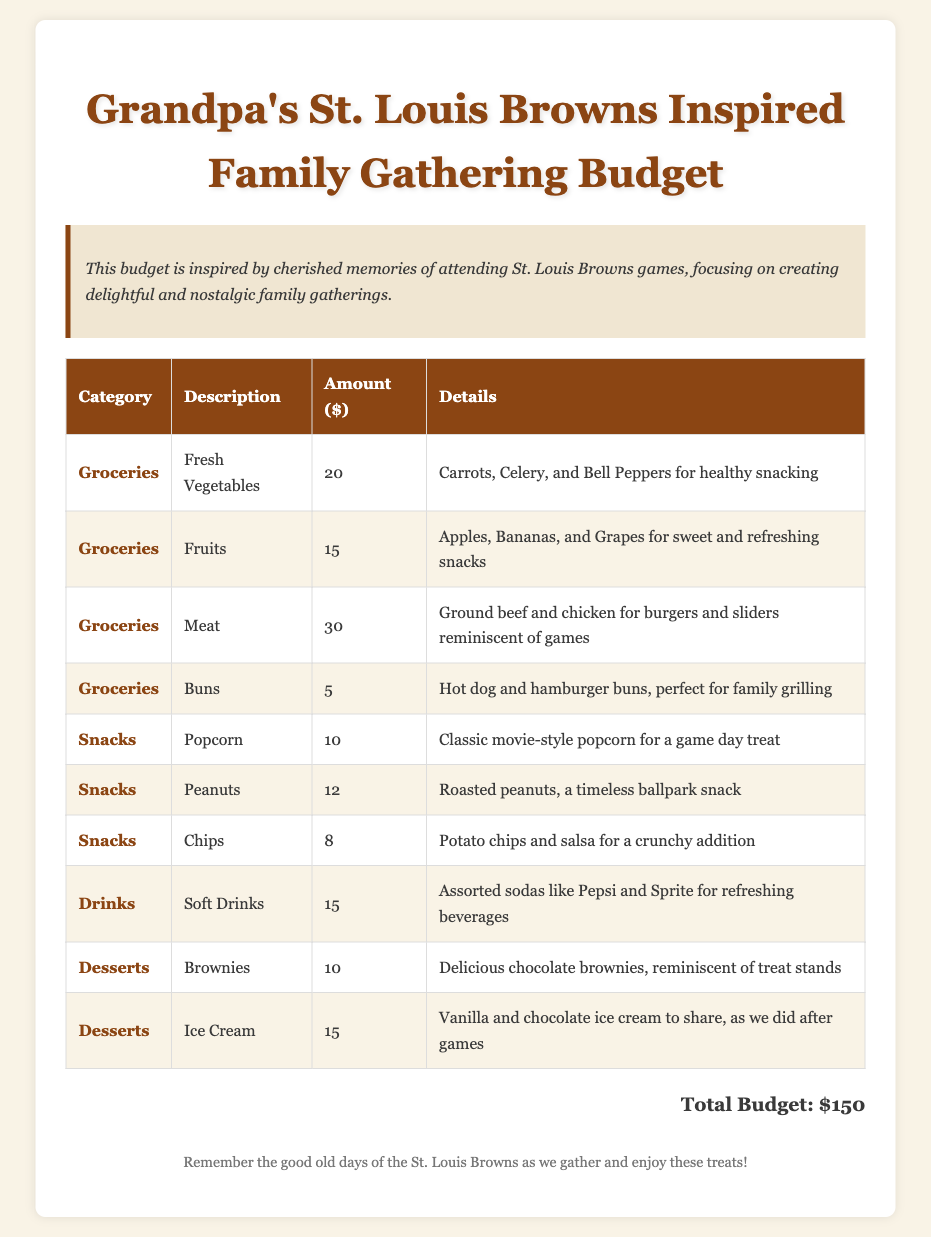What is the total budget? The total budget is stated at the bottom of the document as the cumulative cost of all items listed.
Answer: $150 What is the cost of peanuts? The cost is found in the snack section, specifically for peanuts.
Answer: $12 What type of drinks are listed? The drinks section mentions the specific types included for the gathering.
Answer: Soft Drinks How many different categories of items are listed in the budget? The categories can be counted from the classified rows in the budget table.
Answer: Four What is mentioned as a nostalgic treat after games? The document describes a dessert item that evokes fond memories related to the gathering.
Answer: Ice Cream What fresh vegetables are included in the budget? The listed fresh vegetables can be identified in the groceries section.
Answer: Carrots, Celery, and Bell Peppers What is the cost of popcorn? This cost can be found in the snack category of the itemized budget.
Answer: $10 What type of dessert is included that is reminiscent of treat stands? The document specifies a certain dessert in the dessert section that evokes nostalgia.
Answer: Brownies 